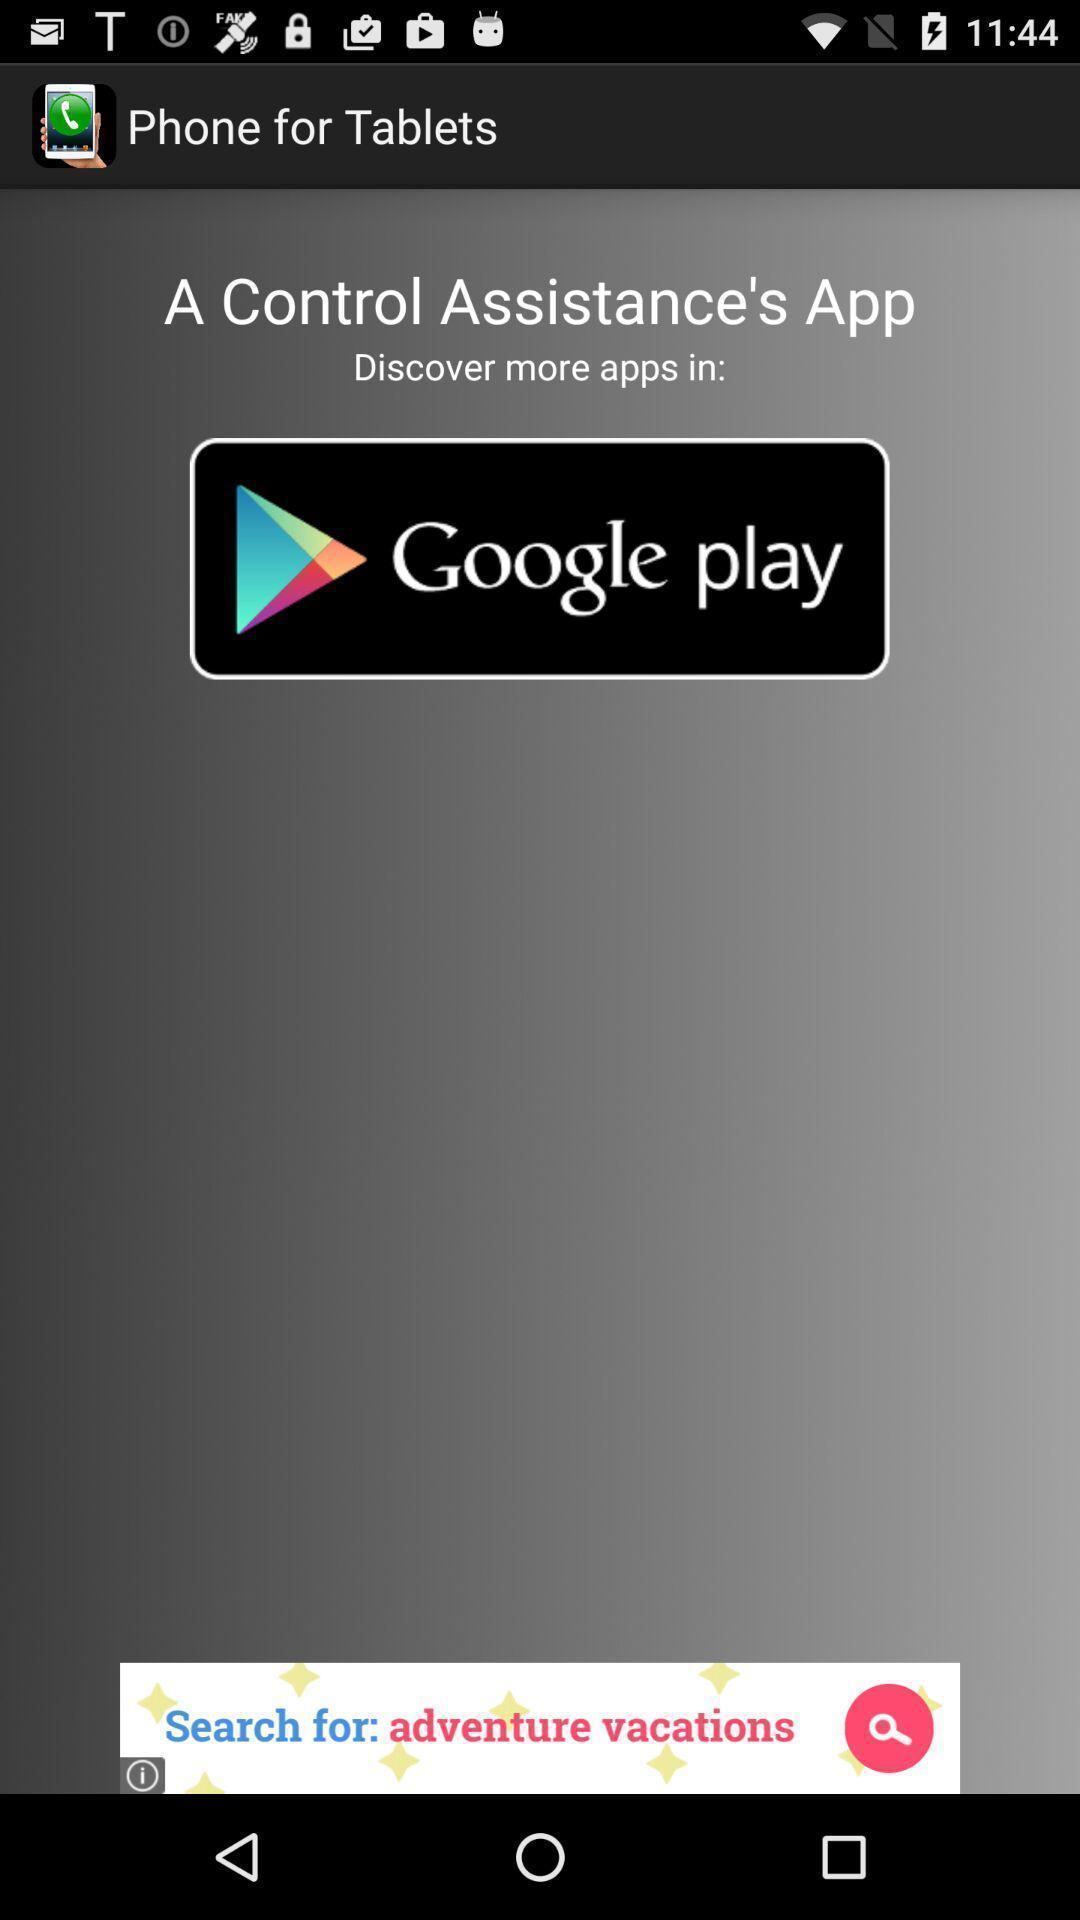Explain what's happening in this screen capture. Page showing an application to download from google play. 